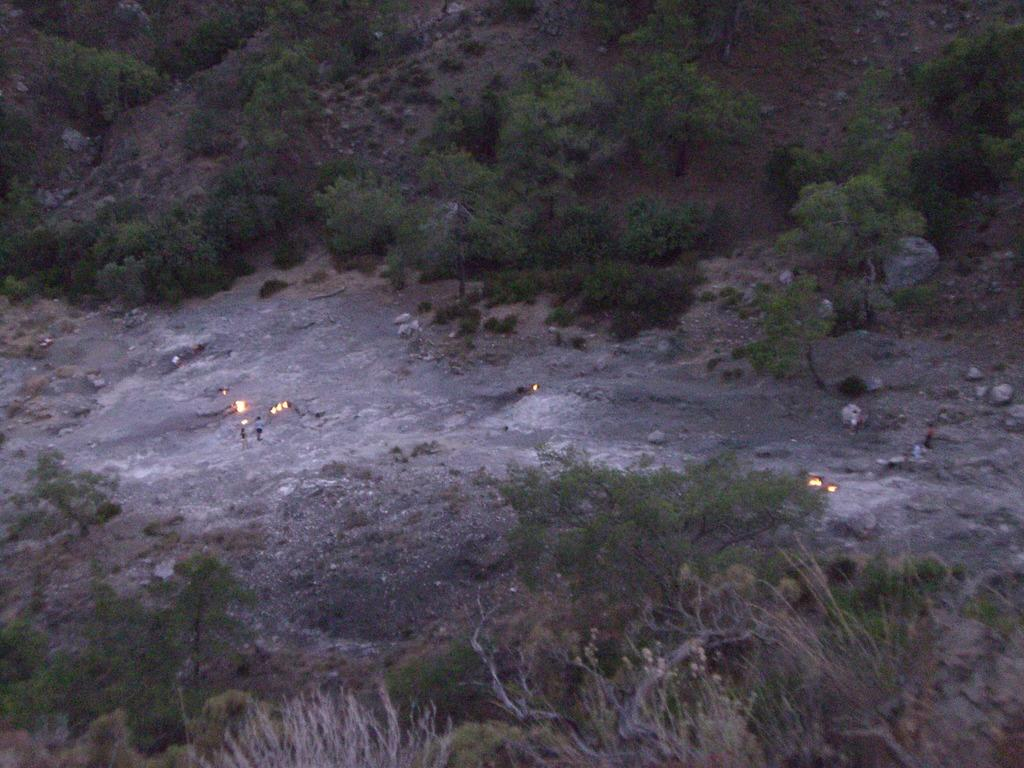What type of vegetation can be seen in the image? There are plants and trees in the image. Where are the plants and trees located? The plants and trees are on the ground in the image. What else can be seen on the ground in the image? There are stones on the land on the right side of the image. How much money is being exchanged between the celery and the vest in the image? There is no celery or vest present in the image, so no such exchange can be observed. 